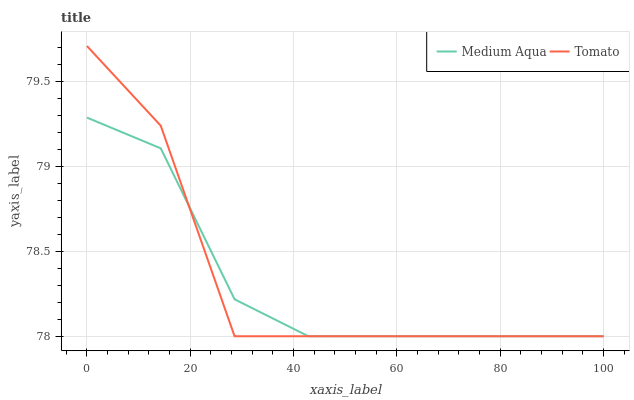Does Medium Aqua have the minimum area under the curve?
Answer yes or no. Yes. Does Tomato have the maximum area under the curve?
Answer yes or no. Yes. Does Medium Aqua have the maximum area under the curve?
Answer yes or no. No. Is Medium Aqua the smoothest?
Answer yes or no. Yes. Is Tomato the roughest?
Answer yes or no. Yes. Is Medium Aqua the roughest?
Answer yes or no. No. Does Medium Aqua have the highest value?
Answer yes or no. No. 